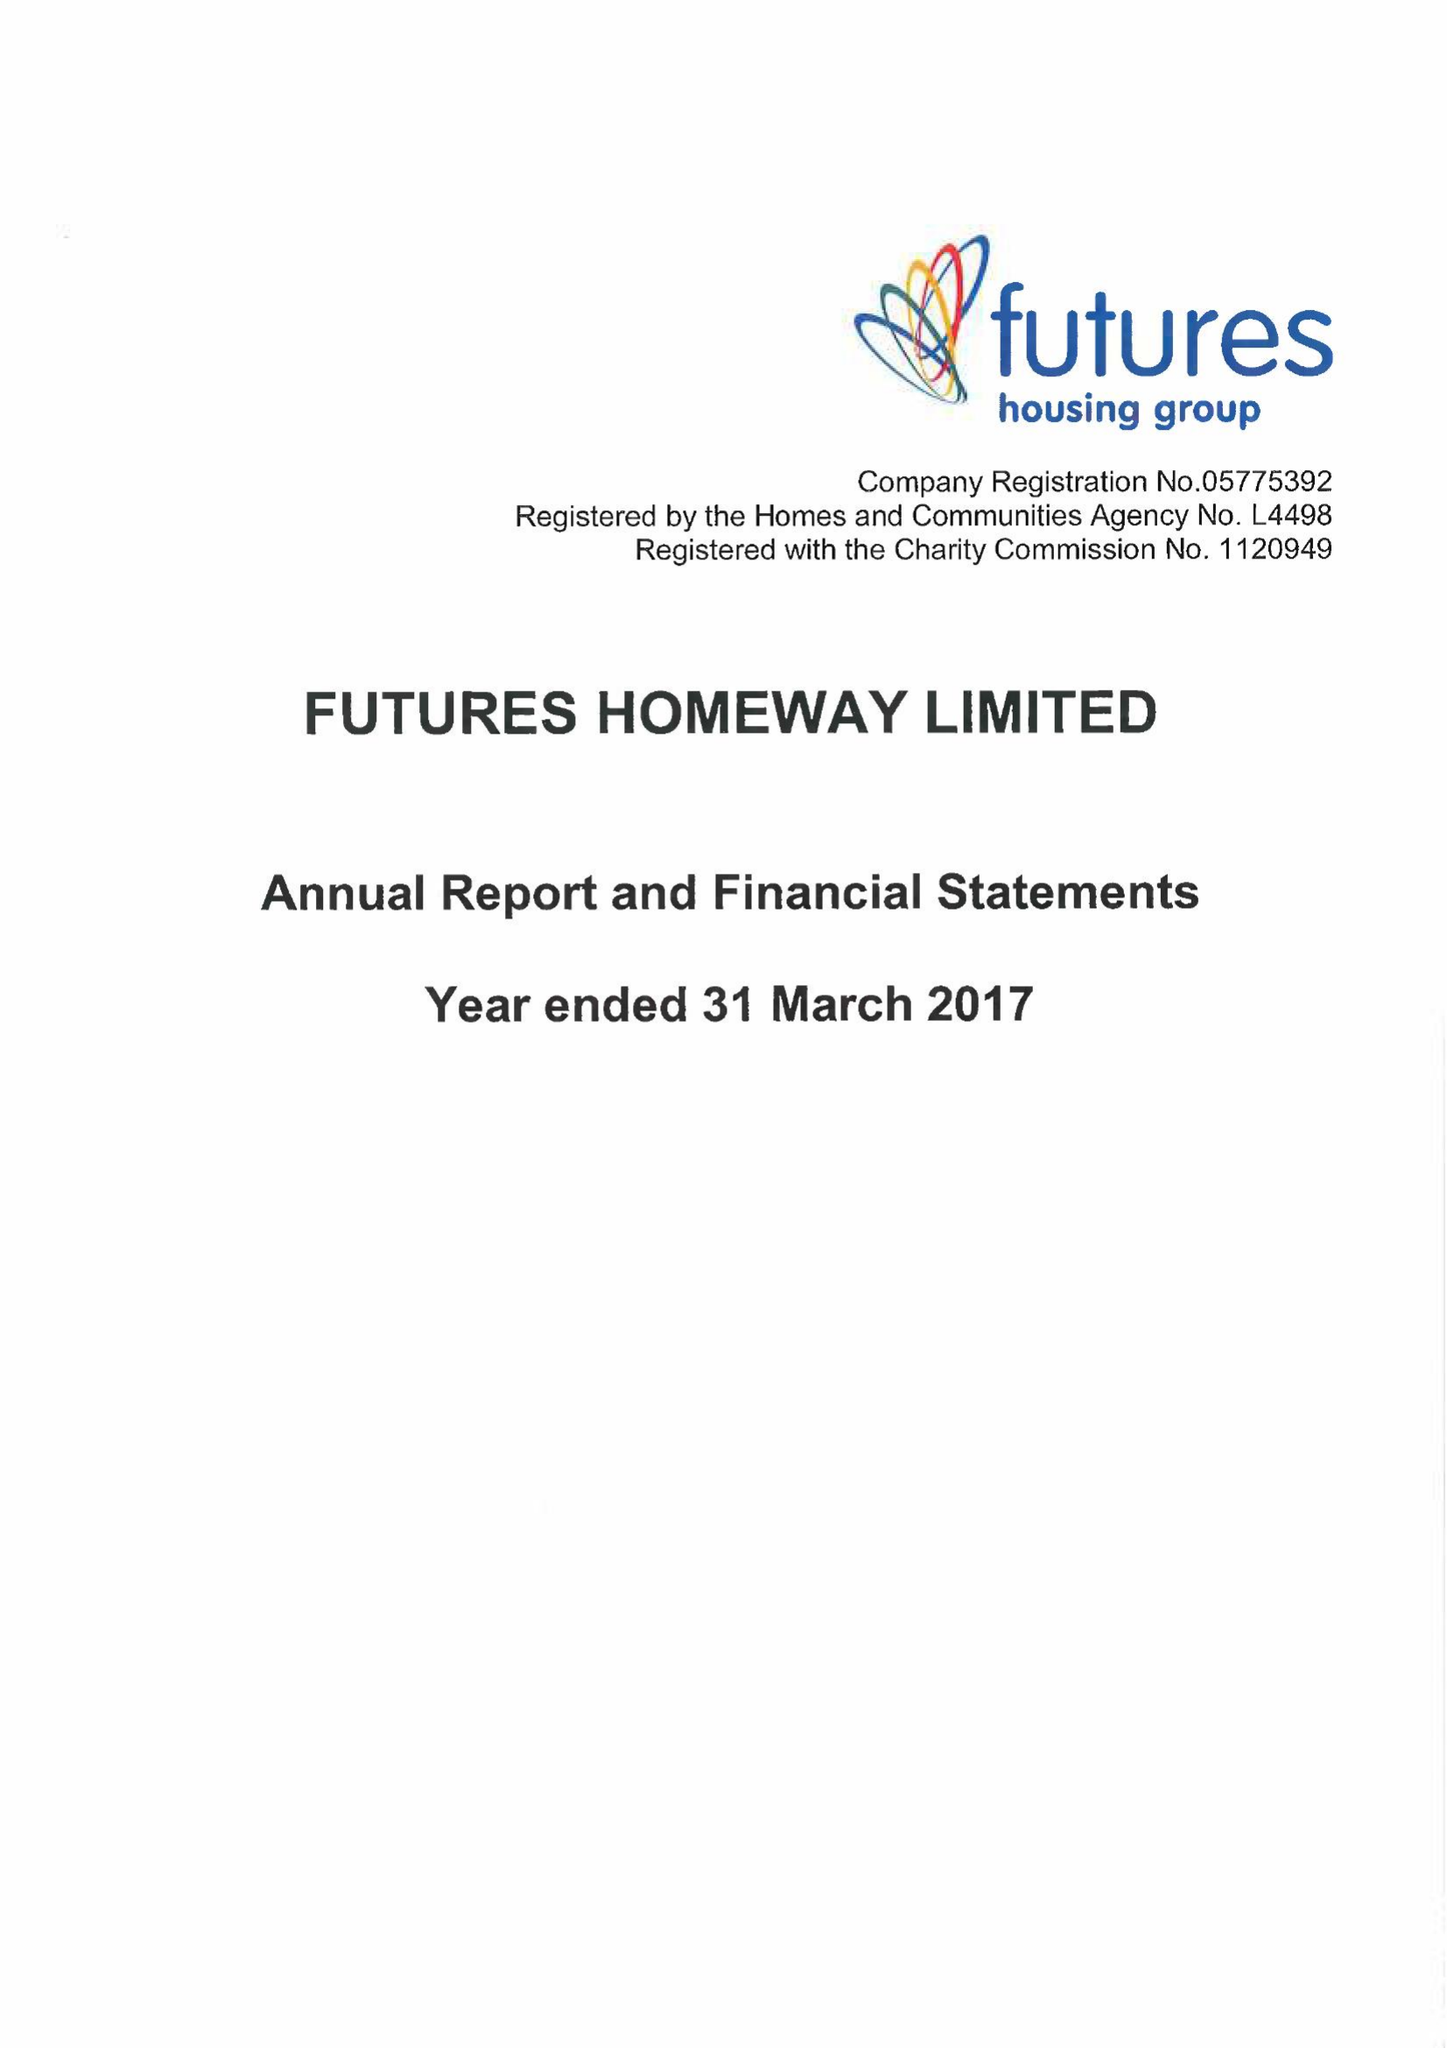What is the value for the address__street_line?
Answer the question using a single word or phrase. None 